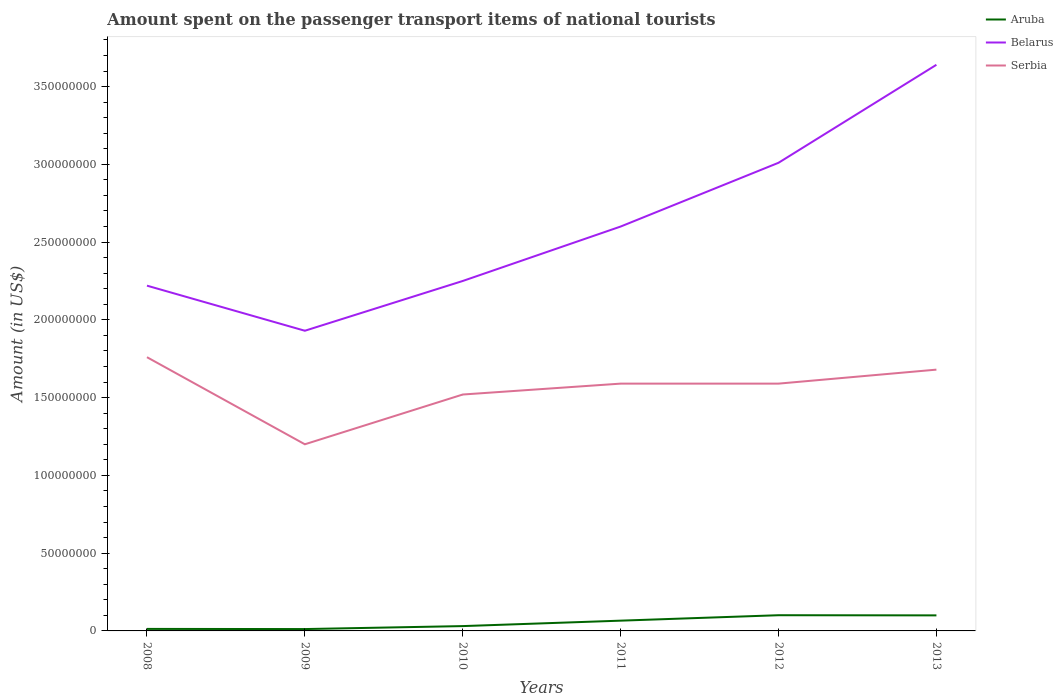Does the line corresponding to Aruba intersect with the line corresponding to Serbia?
Make the answer very short. No. Is the number of lines equal to the number of legend labels?
Your answer should be compact. Yes. Across all years, what is the maximum amount spent on the passenger transport items of national tourists in Belarus?
Provide a short and direct response. 1.93e+08. What is the total amount spent on the passenger transport items of national tourists in Aruba in the graph?
Give a very brief answer. -5.30e+06. What is the difference between the highest and the second highest amount spent on the passenger transport items of national tourists in Serbia?
Offer a very short reply. 5.60e+07. What is the difference between the highest and the lowest amount spent on the passenger transport items of national tourists in Belarus?
Your response must be concise. 2. Is the amount spent on the passenger transport items of national tourists in Aruba strictly greater than the amount spent on the passenger transport items of national tourists in Belarus over the years?
Make the answer very short. Yes. How many lines are there?
Keep it short and to the point. 3. What is the difference between two consecutive major ticks on the Y-axis?
Your response must be concise. 5.00e+07. Are the values on the major ticks of Y-axis written in scientific E-notation?
Your answer should be compact. No. Does the graph contain any zero values?
Give a very brief answer. No. Does the graph contain grids?
Provide a succinct answer. No. How are the legend labels stacked?
Give a very brief answer. Vertical. What is the title of the graph?
Ensure brevity in your answer.  Amount spent on the passenger transport items of national tourists. What is the label or title of the X-axis?
Ensure brevity in your answer.  Years. What is the Amount (in US$) of Aruba in 2008?
Ensure brevity in your answer.  1.30e+06. What is the Amount (in US$) of Belarus in 2008?
Ensure brevity in your answer.  2.22e+08. What is the Amount (in US$) of Serbia in 2008?
Your answer should be very brief. 1.76e+08. What is the Amount (in US$) in Aruba in 2009?
Your answer should be very brief. 1.20e+06. What is the Amount (in US$) in Belarus in 2009?
Offer a very short reply. 1.93e+08. What is the Amount (in US$) of Serbia in 2009?
Your answer should be very brief. 1.20e+08. What is the Amount (in US$) of Aruba in 2010?
Your answer should be compact. 3.10e+06. What is the Amount (in US$) of Belarus in 2010?
Provide a succinct answer. 2.25e+08. What is the Amount (in US$) of Serbia in 2010?
Offer a terse response. 1.52e+08. What is the Amount (in US$) of Aruba in 2011?
Give a very brief answer. 6.60e+06. What is the Amount (in US$) of Belarus in 2011?
Make the answer very short. 2.60e+08. What is the Amount (in US$) of Serbia in 2011?
Keep it short and to the point. 1.59e+08. What is the Amount (in US$) in Aruba in 2012?
Offer a very short reply. 1.01e+07. What is the Amount (in US$) of Belarus in 2012?
Give a very brief answer. 3.01e+08. What is the Amount (in US$) in Serbia in 2012?
Make the answer very short. 1.59e+08. What is the Amount (in US$) in Belarus in 2013?
Provide a short and direct response. 3.64e+08. What is the Amount (in US$) in Serbia in 2013?
Provide a short and direct response. 1.68e+08. Across all years, what is the maximum Amount (in US$) of Aruba?
Offer a terse response. 1.01e+07. Across all years, what is the maximum Amount (in US$) in Belarus?
Keep it short and to the point. 3.64e+08. Across all years, what is the maximum Amount (in US$) of Serbia?
Make the answer very short. 1.76e+08. Across all years, what is the minimum Amount (in US$) in Aruba?
Offer a very short reply. 1.20e+06. Across all years, what is the minimum Amount (in US$) of Belarus?
Provide a short and direct response. 1.93e+08. Across all years, what is the minimum Amount (in US$) in Serbia?
Your response must be concise. 1.20e+08. What is the total Amount (in US$) of Aruba in the graph?
Offer a terse response. 3.23e+07. What is the total Amount (in US$) of Belarus in the graph?
Offer a very short reply. 1.56e+09. What is the total Amount (in US$) of Serbia in the graph?
Keep it short and to the point. 9.34e+08. What is the difference between the Amount (in US$) of Belarus in 2008 and that in 2009?
Offer a very short reply. 2.90e+07. What is the difference between the Amount (in US$) in Serbia in 2008 and that in 2009?
Your answer should be compact. 5.60e+07. What is the difference between the Amount (in US$) of Aruba in 2008 and that in 2010?
Give a very brief answer. -1.80e+06. What is the difference between the Amount (in US$) in Serbia in 2008 and that in 2010?
Your response must be concise. 2.40e+07. What is the difference between the Amount (in US$) of Aruba in 2008 and that in 2011?
Make the answer very short. -5.30e+06. What is the difference between the Amount (in US$) of Belarus in 2008 and that in 2011?
Your answer should be very brief. -3.80e+07. What is the difference between the Amount (in US$) in Serbia in 2008 and that in 2011?
Give a very brief answer. 1.70e+07. What is the difference between the Amount (in US$) in Aruba in 2008 and that in 2012?
Give a very brief answer. -8.80e+06. What is the difference between the Amount (in US$) of Belarus in 2008 and that in 2012?
Your answer should be very brief. -7.90e+07. What is the difference between the Amount (in US$) of Serbia in 2008 and that in 2012?
Keep it short and to the point. 1.70e+07. What is the difference between the Amount (in US$) of Aruba in 2008 and that in 2013?
Your answer should be compact. -8.70e+06. What is the difference between the Amount (in US$) of Belarus in 2008 and that in 2013?
Your answer should be very brief. -1.42e+08. What is the difference between the Amount (in US$) of Serbia in 2008 and that in 2013?
Give a very brief answer. 8.00e+06. What is the difference between the Amount (in US$) of Aruba in 2009 and that in 2010?
Provide a succinct answer. -1.90e+06. What is the difference between the Amount (in US$) of Belarus in 2009 and that in 2010?
Provide a short and direct response. -3.20e+07. What is the difference between the Amount (in US$) in Serbia in 2009 and that in 2010?
Offer a terse response. -3.20e+07. What is the difference between the Amount (in US$) of Aruba in 2009 and that in 2011?
Keep it short and to the point. -5.40e+06. What is the difference between the Amount (in US$) in Belarus in 2009 and that in 2011?
Offer a terse response. -6.70e+07. What is the difference between the Amount (in US$) of Serbia in 2009 and that in 2011?
Your answer should be compact. -3.90e+07. What is the difference between the Amount (in US$) of Aruba in 2009 and that in 2012?
Keep it short and to the point. -8.90e+06. What is the difference between the Amount (in US$) of Belarus in 2009 and that in 2012?
Provide a short and direct response. -1.08e+08. What is the difference between the Amount (in US$) in Serbia in 2009 and that in 2012?
Your response must be concise. -3.90e+07. What is the difference between the Amount (in US$) in Aruba in 2009 and that in 2013?
Keep it short and to the point. -8.80e+06. What is the difference between the Amount (in US$) of Belarus in 2009 and that in 2013?
Give a very brief answer. -1.71e+08. What is the difference between the Amount (in US$) in Serbia in 2009 and that in 2013?
Your response must be concise. -4.80e+07. What is the difference between the Amount (in US$) in Aruba in 2010 and that in 2011?
Keep it short and to the point. -3.50e+06. What is the difference between the Amount (in US$) of Belarus in 2010 and that in 2011?
Provide a short and direct response. -3.50e+07. What is the difference between the Amount (in US$) of Serbia in 2010 and that in 2011?
Offer a very short reply. -7.00e+06. What is the difference between the Amount (in US$) of Aruba in 2010 and that in 2012?
Offer a terse response. -7.00e+06. What is the difference between the Amount (in US$) in Belarus in 2010 and that in 2012?
Provide a short and direct response. -7.60e+07. What is the difference between the Amount (in US$) in Serbia in 2010 and that in 2012?
Keep it short and to the point. -7.00e+06. What is the difference between the Amount (in US$) of Aruba in 2010 and that in 2013?
Offer a very short reply. -6.90e+06. What is the difference between the Amount (in US$) of Belarus in 2010 and that in 2013?
Your answer should be very brief. -1.39e+08. What is the difference between the Amount (in US$) of Serbia in 2010 and that in 2013?
Give a very brief answer. -1.60e+07. What is the difference between the Amount (in US$) of Aruba in 2011 and that in 2012?
Offer a terse response. -3.50e+06. What is the difference between the Amount (in US$) of Belarus in 2011 and that in 2012?
Ensure brevity in your answer.  -4.10e+07. What is the difference between the Amount (in US$) in Aruba in 2011 and that in 2013?
Make the answer very short. -3.40e+06. What is the difference between the Amount (in US$) in Belarus in 2011 and that in 2013?
Your answer should be compact. -1.04e+08. What is the difference between the Amount (in US$) in Serbia in 2011 and that in 2013?
Make the answer very short. -9.00e+06. What is the difference between the Amount (in US$) of Belarus in 2012 and that in 2013?
Keep it short and to the point. -6.30e+07. What is the difference between the Amount (in US$) of Serbia in 2012 and that in 2013?
Make the answer very short. -9.00e+06. What is the difference between the Amount (in US$) in Aruba in 2008 and the Amount (in US$) in Belarus in 2009?
Offer a terse response. -1.92e+08. What is the difference between the Amount (in US$) of Aruba in 2008 and the Amount (in US$) of Serbia in 2009?
Your answer should be very brief. -1.19e+08. What is the difference between the Amount (in US$) of Belarus in 2008 and the Amount (in US$) of Serbia in 2009?
Your answer should be compact. 1.02e+08. What is the difference between the Amount (in US$) of Aruba in 2008 and the Amount (in US$) of Belarus in 2010?
Provide a succinct answer. -2.24e+08. What is the difference between the Amount (in US$) in Aruba in 2008 and the Amount (in US$) in Serbia in 2010?
Make the answer very short. -1.51e+08. What is the difference between the Amount (in US$) in Belarus in 2008 and the Amount (in US$) in Serbia in 2010?
Ensure brevity in your answer.  7.00e+07. What is the difference between the Amount (in US$) of Aruba in 2008 and the Amount (in US$) of Belarus in 2011?
Your response must be concise. -2.59e+08. What is the difference between the Amount (in US$) in Aruba in 2008 and the Amount (in US$) in Serbia in 2011?
Offer a terse response. -1.58e+08. What is the difference between the Amount (in US$) in Belarus in 2008 and the Amount (in US$) in Serbia in 2011?
Offer a very short reply. 6.30e+07. What is the difference between the Amount (in US$) in Aruba in 2008 and the Amount (in US$) in Belarus in 2012?
Your response must be concise. -3.00e+08. What is the difference between the Amount (in US$) of Aruba in 2008 and the Amount (in US$) of Serbia in 2012?
Give a very brief answer. -1.58e+08. What is the difference between the Amount (in US$) in Belarus in 2008 and the Amount (in US$) in Serbia in 2012?
Offer a very short reply. 6.30e+07. What is the difference between the Amount (in US$) in Aruba in 2008 and the Amount (in US$) in Belarus in 2013?
Ensure brevity in your answer.  -3.63e+08. What is the difference between the Amount (in US$) in Aruba in 2008 and the Amount (in US$) in Serbia in 2013?
Give a very brief answer. -1.67e+08. What is the difference between the Amount (in US$) in Belarus in 2008 and the Amount (in US$) in Serbia in 2013?
Offer a very short reply. 5.40e+07. What is the difference between the Amount (in US$) of Aruba in 2009 and the Amount (in US$) of Belarus in 2010?
Give a very brief answer. -2.24e+08. What is the difference between the Amount (in US$) of Aruba in 2009 and the Amount (in US$) of Serbia in 2010?
Make the answer very short. -1.51e+08. What is the difference between the Amount (in US$) in Belarus in 2009 and the Amount (in US$) in Serbia in 2010?
Ensure brevity in your answer.  4.10e+07. What is the difference between the Amount (in US$) in Aruba in 2009 and the Amount (in US$) in Belarus in 2011?
Give a very brief answer. -2.59e+08. What is the difference between the Amount (in US$) in Aruba in 2009 and the Amount (in US$) in Serbia in 2011?
Offer a terse response. -1.58e+08. What is the difference between the Amount (in US$) of Belarus in 2009 and the Amount (in US$) of Serbia in 2011?
Ensure brevity in your answer.  3.40e+07. What is the difference between the Amount (in US$) in Aruba in 2009 and the Amount (in US$) in Belarus in 2012?
Offer a very short reply. -3.00e+08. What is the difference between the Amount (in US$) of Aruba in 2009 and the Amount (in US$) of Serbia in 2012?
Offer a very short reply. -1.58e+08. What is the difference between the Amount (in US$) of Belarus in 2009 and the Amount (in US$) of Serbia in 2012?
Offer a very short reply. 3.40e+07. What is the difference between the Amount (in US$) in Aruba in 2009 and the Amount (in US$) in Belarus in 2013?
Ensure brevity in your answer.  -3.63e+08. What is the difference between the Amount (in US$) in Aruba in 2009 and the Amount (in US$) in Serbia in 2013?
Provide a succinct answer. -1.67e+08. What is the difference between the Amount (in US$) in Belarus in 2009 and the Amount (in US$) in Serbia in 2013?
Ensure brevity in your answer.  2.50e+07. What is the difference between the Amount (in US$) in Aruba in 2010 and the Amount (in US$) in Belarus in 2011?
Give a very brief answer. -2.57e+08. What is the difference between the Amount (in US$) in Aruba in 2010 and the Amount (in US$) in Serbia in 2011?
Make the answer very short. -1.56e+08. What is the difference between the Amount (in US$) of Belarus in 2010 and the Amount (in US$) of Serbia in 2011?
Keep it short and to the point. 6.60e+07. What is the difference between the Amount (in US$) in Aruba in 2010 and the Amount (in US$) in Belarus in 2012?
Give a very brief answer. -2.98e+08. What is the difference between the Amount (in US$) in Aruba in 2010 and the Amount (in US$) in Serbia in 2012?
Ensure brevity in your answer.  -1.56e+08. What is the difference between the Amount (in US$) of Belarus in 2010 and the Amount (in US$) of Serbia in 2012?
Your answer should be very brief. 6.60e+07. What is the difference between the Amount (in US$) in Aruba in 2010 and the Amount (in US$) in Belarus in 2013?
Give a very brief answer. -3.61e+08. What is the difference between the Amount (in US$) of Aruba in 2010 and the Amount (in US$) of Serbia in 2013?
Provide a short and direct response. -1.65e+08. What is the difference between the Amount (in US$) of Belarus in 2010 and the Amount (in US$) of Serbia in 2013?
Your answer should be compact. 5.70e+07. What is the difference between the Amount (in US$) in Aruba in 2011 and the Amount (in US$) in Belarus in 2012?
Make the answer very short. -2.94e+08. What is the difference between the Amount (in US$) of Aruba in 2011 and the Amount (in US$) of Serbia in 2012?
Offer a very short reply. -1.52e+08. What is the difference between the Amount (in US$) of Belarus in 2011 and the Amount (in US$) of Serbia in 2012?
Provide a succinct answer. 1.01e+08. What is the difference between the Amount (in US$) in Aruba in 2011 and the Amount (in US$) in Belarus in 2013?
Your response must be concise. -3.57e+08. What is the difference between the Amount (in US$) of Aruba in 2011 and the Amount (in US$) of Serbia in 2013?
Offer a terse response. -1.61e+08. What is the difference between the Amount (in US$) in Belarus in 2011 and the Amount (in US$) in Serbia in 2013?
Your response must be concise. 9.20e+07. What is the difference between the Amount (in US$) in Aruba in 2012 and the Amount (in US$) in Belarus in 2013?
Ensure brevity in your answer.  -3.54e+08. What is the difference between the Amount (in US$) in Aruba in 2012 and the Amount (in US$) in Serbia in 2013?
Your response must be concise. -1.58e+08. What is the difference between the Amount (in US$) of Belarus in 2012 and the Amount (in US$) of Serbia in 2013?
Offer a very short reply. 1.33e+08. What is the average Amount (in US$) in Aruba per year?
Make the answer very short. 5.38e+06. What is the average Amount (in US$) in Belarus per year?
Your answer should be very brief. 2.61e+08. What is the average Amount (in US$) in Serbia per year?
Offer a very short reply. 1.56e+08. In the year 2008, what is the difference between the Amount (in US$) in Aruba and Amount (in US$) in Belarus?
Your response must be concise. -2.21e+08. In the year 2008, what is the difference between the Amount (in US$) in Aruba and Amount (in US$) in Serbia?
Provide a short and direct response. -1.75e+08. In the year 2008, what is the difference between the Amount (in US$) in Belarus and Amount (in US$) in Serbia?
Your answer should be compact. 4.60e+07. In the year 2009, what is the difference between the Amount (in US$) in Aruba and Amount (in US$) in Belarus?
Ensure brevity in your answer.  -1.92e+08. In the year 2009, what is the difference between the Amount (in US$) of Aruba and Amount (in US$) of Serbia?
Provide a short and direct response. -1.19e+08. In the year 2009, what is the difference between the Amount (in US$) in Belarus and Amount (in US$) in Serbia?
Provide a short and direct response. 7.30e+07. In the year 2010, what is the difference between the Amount (in US$) in Aruba and Amount (in US$) in Belarus?
Give a very brief answer. -2.22e+08. In the year 2010, what is the difference between the Amount (in US$) of Aruba and Amount (in US$) of Serbia?
Provide a short and direct response. -1.49e+08. In the year 2010, what is the difference between the Amount (in US$) in Belarus and Amount (in US$) in Serbia?
Provide a succinct answer. 7.30e+07. In the year 2011, what is the difference between the Amount (in US$) in Aruba and Amount (in US$) in Belarus?
Give a very brief answer. -2.53e+08. In the year 2011, what is the difference between the Amount (in US$) in Aruba and Amount (in US$) in Serbia?
Provide a short and direct response. -1.52e+08. In the year 2011, what is the difference between the Amount (in US$) of Belarus and Amount (in US$) of Serbia?
Provide a short and direct response. 1.01e+08. In the year 2012, what is the difference between the Amount (in US$) of Aruba and Amount (in US$) of Belarus?
Ensure brevity in your answer.  -2.91e+08. In the year 2012, what is the difference between the Amount (in US$) of Aruba and Amount (in US$) of Serbia?
Your answer should be very brief. -1.49e+08. In the year 2012, what is the difference between the Amount (in US$) of Belarus and Amount (in US$) of Serbia?
Provide a short and direct response. 1.42e+08. In the year 2013, what is the difference between the Amount (in US$) of Aruba and Amount (in US$) of Belarus?
Provide a succinct answer. -3.54e+08. In the year 2013, what is the difference between the Amount (in US$) in Aruba and Amount (in US$) in Serbia?
Offer a very short reply. -1.58e+08. In the year 2013, what is the difference between the Amount (in US$) of Belarus and Amount (in US$) of Serbia?
Your answer should be compact. 1.96e+08. What is the ratio of the Amount (in US$) in Belarus in 2008 to that in 2009?
Offer a very short reply. 1.15. What is the ratio of the Amount (in US$) in Serbia in 2008 to that in 2009?
Ensure brevity in your answer.  1.47. What is the ratio of the Amount (in US$) of Aruba in 2008 to that in 2010?
Give a very brief answer. 0.42. What is the ratio of the Amount (in US$) of Belarus in 2008 to that in 2010?
Provide a short and direct response. 0.99. What is the ratio of the Amount (in US$) of Serbia in 2008 to that in 2010?
Your answer should be compact. 1.16. What is the ratio of the Amount (in US$) of Aruba in 2008 to that in 2011?
Ensure brevity in your answer.  0.2. What is the ratio of the Amount (in US$) of Belarus in 2008 to that in 2011?
Your answer should be very brief. 0.85. What is the ratio of the Amount (in US$) of Serbia in 2008 to that in 2011?
Offer a terse response. 1.11. What is the ratio of the Amount (in US$) of Aruba in 2008 to that in 2012?
Your answer should be very brief. 0.13. What is the ratio of the Amount (in US$) in Belarus in 2008 to that in 2012?
Your answer should be very brief. 0.74. What is the ratio of the Amount (in US$) of Serbia in 2008 to that in 2012?
Provide a succinct answer. 1.11. What is the ratio of the Amount (in US$) of Aruba in 2008 to that in 2013?
Give a very brief answer. 0.13. What is the ratio of the Amount (in US$) of Belarus in 2008 to that in 2013?
Provide a succinct answer. 0.61. What is the ratio of the Amount (in US$) in Serbia in 2008 to that in 2013?
Your answer should be very brief. 1.05. What is the ratio of the Amount (in US$) in Aruba in 2009 to that in 2010?
Give a very brief answer. 0.39. What is the ratio of the Amount (in US$) in Belarus in 2009 to that in 2010?
Make the answer very short. 0.86. What is the ratio of the Amount (in US$) of Serbia in 2009 to that in 2010?
Your answer should be compact. 0.79. What is the ratio of the Amount (in US$) of Aruba in 2009 to that in 2011?
Offer a very short reply. 0.18. What is the ratio of the Amount (in US$) of Belarus in 2009 to that in 2011?
Keep it short and to the point. 0.74. What is the ratio of the Amount (in US$) of Serbia in 2009 to that in 2011?
Your answer should be very brief. 0.75. What is the ratio of the Amount (in US$) of Aruba in 2009 to that in 2012?
Offer a terse response. 0.12. What is the ratio of the Amount (in US$) in Belarus in 2009 to that in 2012?
Ensure brevity in your answer.  0.64. What is the ratio of the Amount (in US$) of Serbia in 2009 to that in 2012?
Make the answer very short. 0.75. What is the ratio of the Amount (in US$) of Aruba in 2009 to that in 2013?
Give a very brief answer. 0.12. What is the ratio of the Amount (in US$) of Belarus in 2009 to that in 2013?
Your response must be concise. 0.53. What is the ratio of the Amount (in US$) of Aruba in 2010 to that in 2011?
Your response must be concise. 0.47. What is the ratio of the Amount (in US$) in Belarus in 2010 to that in 2011?
Provide a succinct answer. 0.87. What is the ratio of the Amount (in US$) in Serbia in 2010 to that in 2011?
Offer a terse response. 0.96. What is the ratio of the Amount (in US$) of Aruba in 2010 to that in 2012?
Give a very brief answer. 0.31. What is the ratio of the Amount (in US$) in Belarus in 2010 to that in 2012?
Your response must be concise. 0.75. What is the ratio of the Amount (in US$) in Serbia in 2010 to that in 2012?
Your answer should be very brief. 0.96. What is the ratio of the Amount (in US$) in Aruba in 2010 to that in 2013?
Offer a very short reply. 0.31. What is the ratio of the Amount (in US$) of Belarus in 2010 to that in 2013?
Your response must be concise. 0.62. What is the ratio of the Amount (in US$) in Serbia in 2010 to that in 2013?
Your response must be concise. 0.9. What is the ratio of the Amount (in US$) in Aruba in 2011 to that in 2012?
Ensure brevity in your answer.  0.65. What is the ratio of the Amount (in US$) of Belarus in 2011 to that in 2012?
Give a very brief answer. 0.86. What is the ratio of the Amount (in US$) in Aruba in 2011 to that in 2013?
Keep it short and to the point. 0.66. What is the ratio of the Amount (in US$) in Belarus in 2011 to that in 2013?
Offer a very short reply. 0.71. What is the ratio of the Amount (in US$) of Serbia in 2011 to that in 2013?
Give a very brief answer. 0.95. What is the ratio of the Amount (in US$) of Belarus in 2012 to that in 2013?
Your response must be concise. 0.83. What is the ratio of the Amount (in US$) of Serbia in 2012 to that in 2013?
Offer a terse response. 0.95. What is the difference between the highest and the second highest Amount (in US$) of Aruba?
Provide a succinct answer. 1.00e+05. What is the difference between the highest and the second highest Amount (in US$) in Belarus?
Ensure brevity in your answer.  6.30e+07. What is the difference between the highest and the second highest Amount (in US$) of Serbia?
Keep it short and to the point. 8.00e+06. What is the difference between the highest and the lowest Amount (in US$) of Aruba?
Your response must be concise. 8.90e+06. What is the difference between the highest and the lowest Amount (in US$) of Belarus?
Your answer should be compact. 1.71e+08. What is the difference between the highest and the lowest Amount (in US$) in Serbia?
Provide a short and direct response. 5.60e+07. 